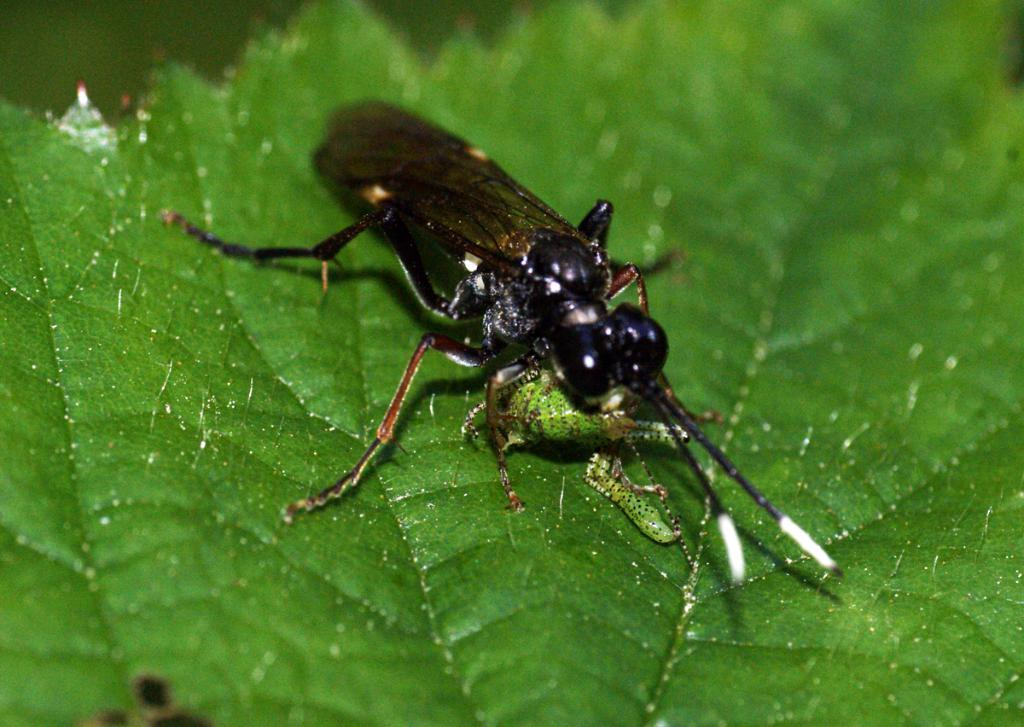What type of creature is in the image? There is an insect in the image. Where is the insect located in relation to the image? The insect is in the front of the image. What is present at the bottom of the image? There is a leaf at the bottom of the image. How would you describe the background of the image? The background of the image is blurry. What type of cracker is being used to print on the leaf in the image? There is no cracker or printing activity present in the image. 